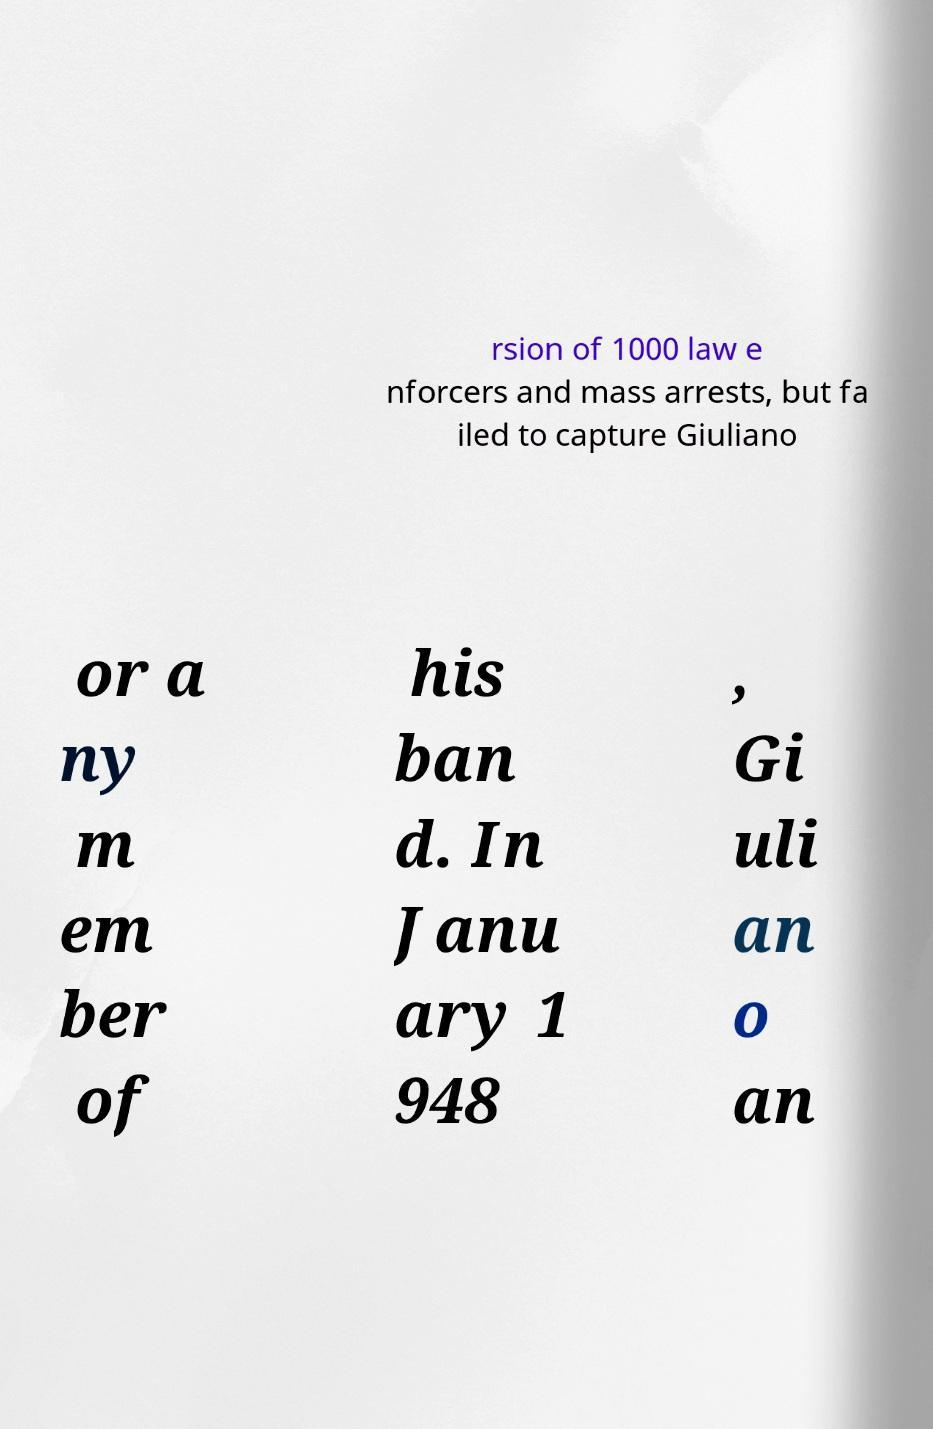What messages or text are displayed in this image? I need them in a readable, typed format. rsion of 1000 law e nforcers and mass arrests, but fa iled to capture Giuliano or a ny m em ber of his ban d. In Janu ary 1 948 , Gi uli an o an 